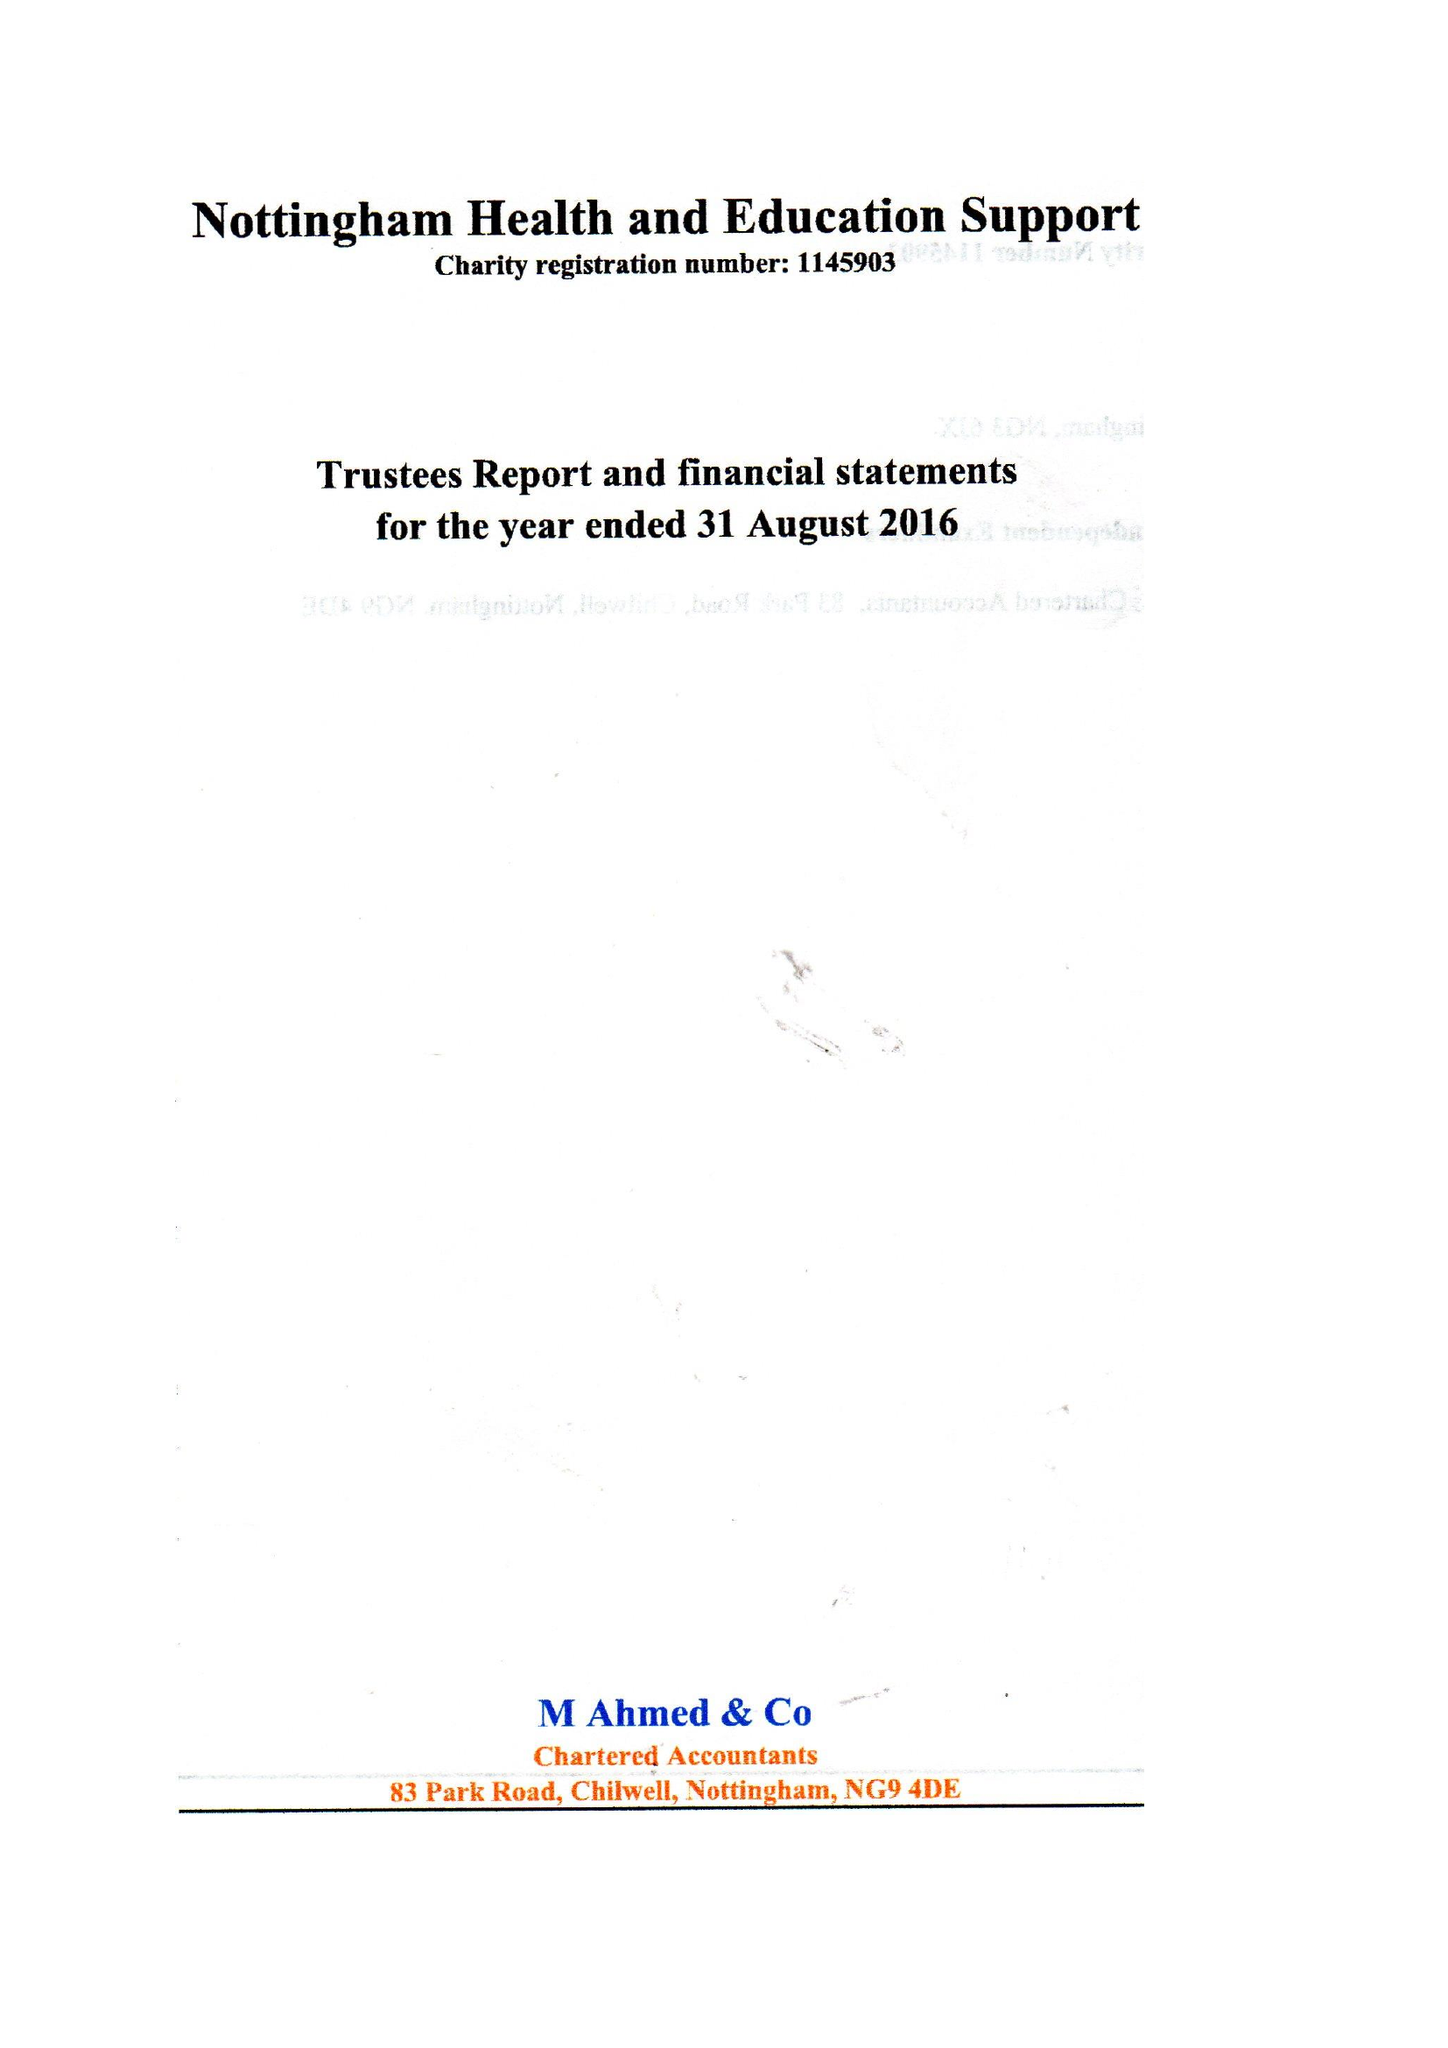What is the value for the spending_annually_in_british_pounds?
Answer the question using a single word or phrase. 85715.00 